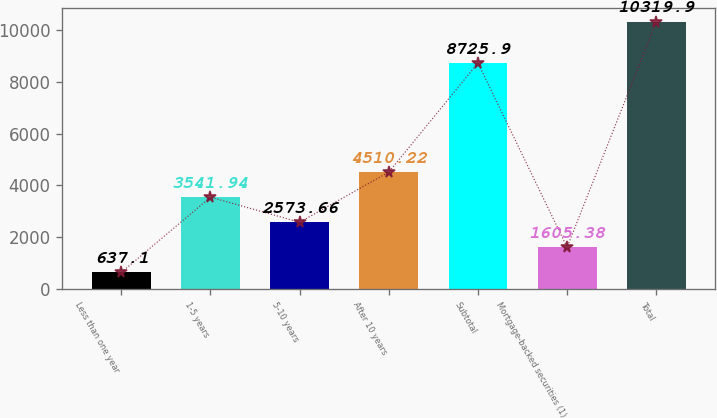<chart> <loc_0><loc_0><loc_500><loc_500><bar_chart><fcel>Less than one year<fcel>1-5 years<fcel>5-10 years<fcel>After 10 years<fcel>Subtotal<fcel>Mortgage-backed securities (1)<fcel>Total<nl><fcel>637.1<fcel>3541.94<fcel>2573.66<fcel>4510.22<fcel>8725.9<fcel>1605.38<fcel>10319.9<nl></chart> 